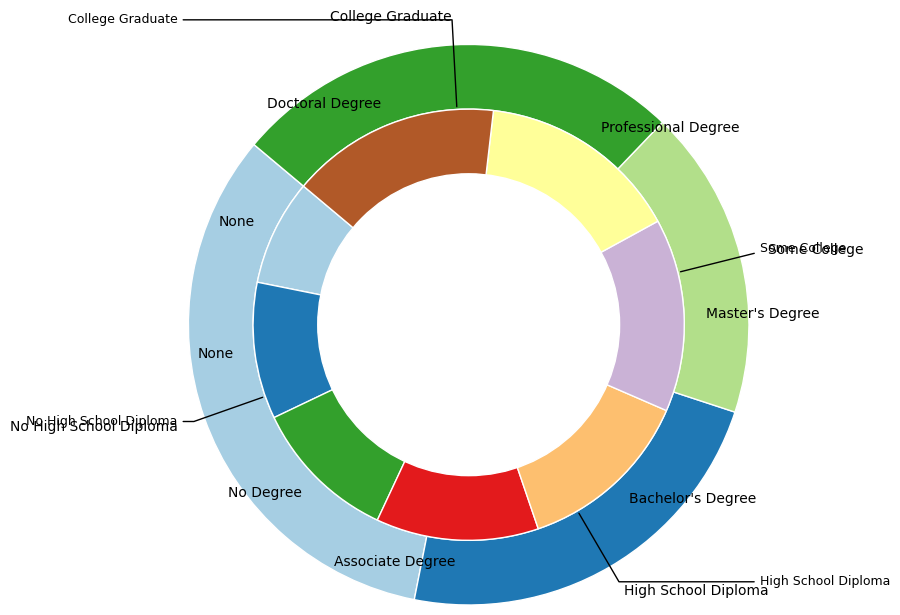What is the employment rate for individuals with a Master’s Degree? To find the employment rate for individuals with a Master’s Degree, locate the segment within the inner pie chart labeled "Master's Degree." The employment rate is explicitly provided next to the label.
Answer: 82 Which education level has the highest average employment rate, and what is it? The outer pie chart provides the different education levels along with their average employment rates. Locate the segment with the highest average rate by comparing the provided values. College Graduates have the highest average employment rate.
Answer: College Graduate, 83 Compare the employment rates of individuals with an Associate Degree and a Bachelor's Degree. Which is higher? Find the segments labeled "Associate Degree" and "Bachelor's Degree" within the inner pie chart. Compare the employment rates associated with these degrees. The Bachelor's Degree employment rate is higher.
Answer: Bachelor's Degree Calculate the difference in employment rates between those with no High School Diploma and those with a Doctoral Degree. Locate "No High School Diploma" and "Doctoral Degree" in the inner pie chart. Subtract the employment rate of "No High School Diploma" from that of "Doctoral Degree." The rates are 45 and 89, respectively.
Answer: 44 Which degree within "College Graduate" has the lowest employment rate? In the inner pie chart, identify all degrees under "College Graduate" and compare their employment rates. The degrees are Bachelor’s, Master’s, Professional, and Doctoral, and the one with the lowest rate is the Bachelor's Degree.
Answer: Bachelor's Degree Order the employment rates of different degrees under "Some College" from highest to lowest. Inside the inner pie chart, find the slices for "Some College," which includes "No Degree" and "Associate Degree." Compare their employment rates.
Answer: Associate Degree, No Degree What is the average employment rate of all categories within "College Graduate"? Identify the segments under "College Graduate," which include Bachelor’s, Master’s, Professional, and Doctoral Degrees. Calculate their average by combining their rates (75+82+86+89) and dividing by 4.
Answer: 83 How does the employment rate of individuals with a Professional Degree compare to those with a Bachelor's Degree? Compare the segments within "College Graduate" labeled "Professional Degree" and "Bachelor's Degree." The employment rate for Professional Degree holders is higher than that for Bachelor's Degree holders.
Answer: Professional Degree is higher Identify the education level with the lowest average employment rate. Observe the outer pie chart and compare the average employment rates of each education level. The one with the lowest rate is "No High School Diploma."
Answer: No High School Diploma Which degree has an employment rate closest to the overall average employment rate of College Graduates? First, calculate the average employment rate of all College Graduate categories (Bachelor’s, Master’s, Professional, and Doctoral). Then, find the degree within this group with a rate closest to this average. The average is 83, and the closest rate is that of the Master's Degree at 82.
Answer: Master's Degree 